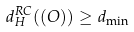<formula> <loc_0><loc_0><loc_500><loc_500>d _ { H } ^ { R C } ( ( O ) ) \geq d _ { \min }</formula> 